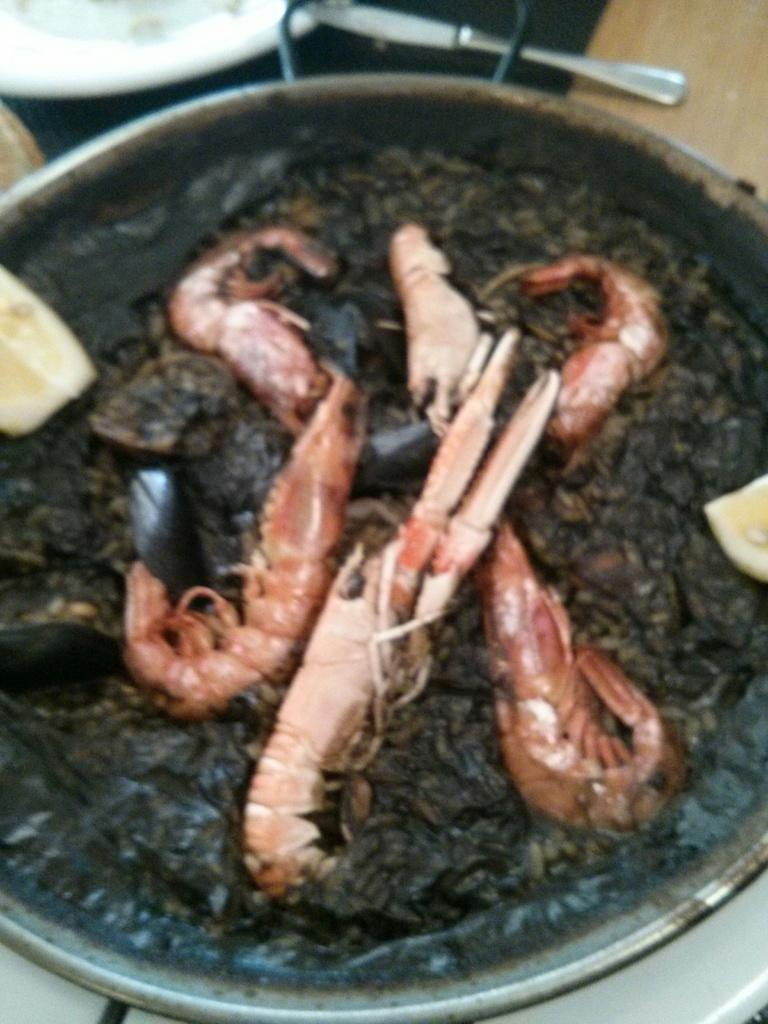What is being cooked or prepared in the pan in the image? The image shows food items in a pan, but it does not specify what type of food is being prepared. What is on the table in the image? There is a plate and a knife on the table in the image. How many houses can be seen in the image? There are no houses present in the image. What type of cart is being used to transport the food items in the image? There is no cart present in the image; the food items are in a pan. 